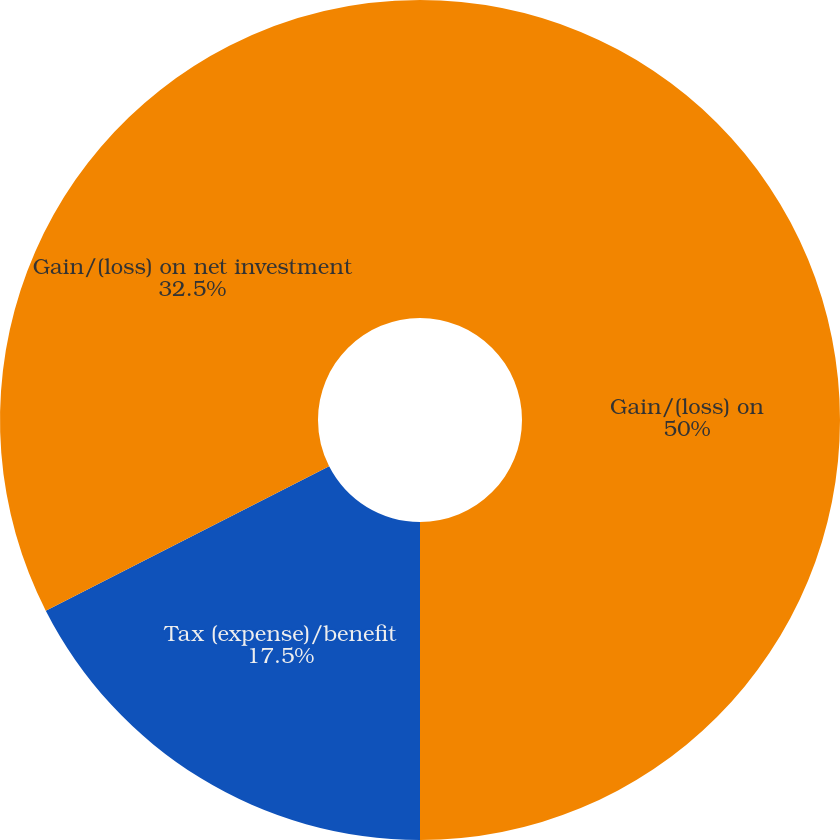Convert chart to OTSL. <chart><loc_0><loc_0><loc_500><loc_500><pie_chart><fcel>Gain/(loss) on<fcel>Tax (expense)/benefit<fcel>Gain/(loss) on net investment<nl><fcel>50.0%<fcel>17.5%<fcel>32.5%<nl></chart> 